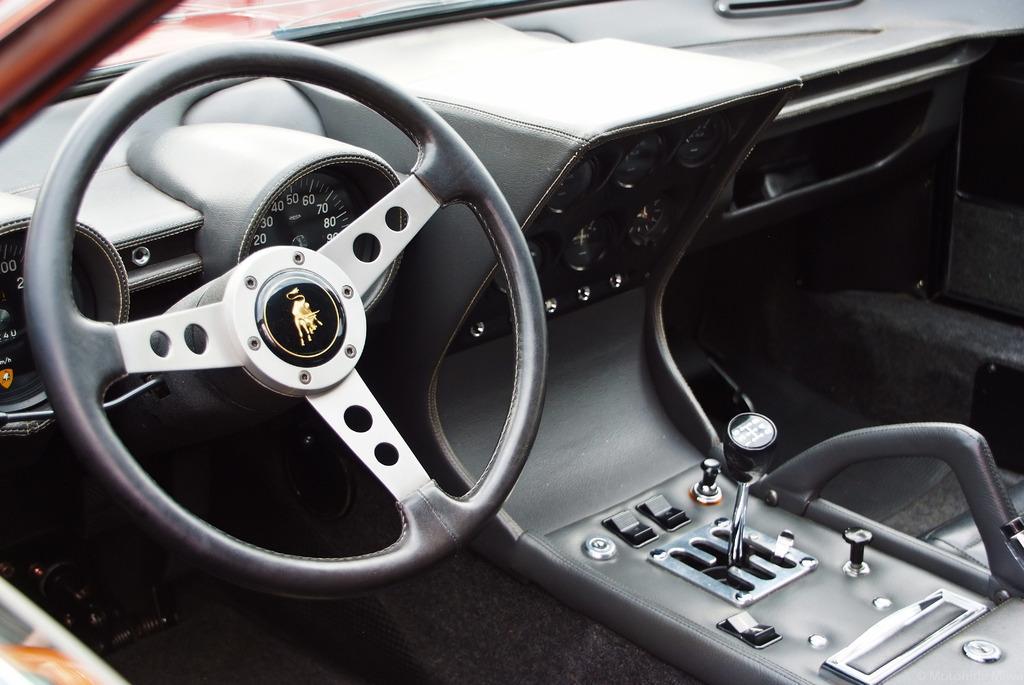Describe this image in one or two sentences. This is a inside view of a car as we can see there is a steering on the left side of this image and there is a gearing system in the bottom of this image. 